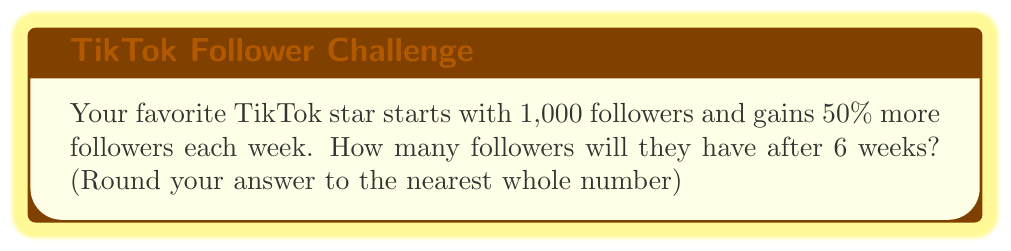Solve this math problem. Let's break this down step-by-step:

1) We start with 1,000 followers.
2) Each week, the number of followers increases by 50%, which means it multiplies by 1.5.
3) This happens for 6 weeks.

We can represent this mathematically as:

$$ \text{Final Followers} = 1000 \times (1.5)^6 $$

Let's calculate:

$$ \begin{align}
1000 \times (1.5)^6 &= 1000 \times 11.390625 \\
&= 11,390.625
\end{align} $$

Rounding to the nearest whole number:

$$ 11,390.625 \approx 11,391 $$
Answer: 11,391 followers 